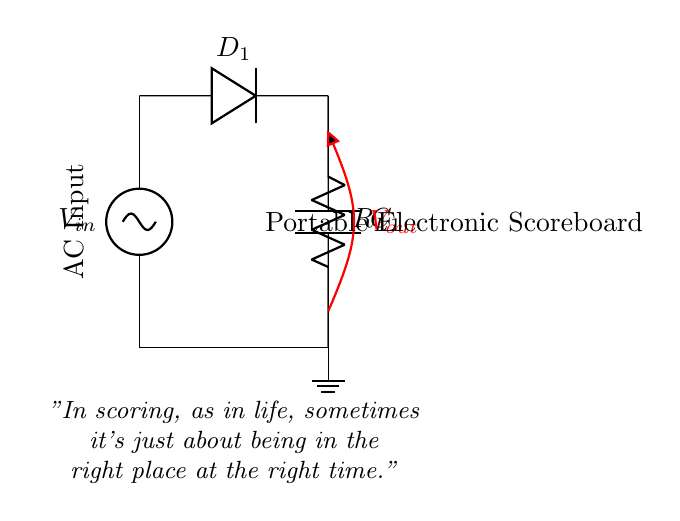What type of rectifier is used in this circuit? The circuit diagram shows a half-wave rectifier as it includes only one diode, which allows current to pass only during one half of the input AC cycle.
Answer: half-wave What is the function of the diode in this circuit? The diode (D1) allows current to flow only in one direction, thereby converting AC voltage to pulsed DC voltage, which is characteristic of a rectifier.
Answer: convert AC to DC What is the role of the capacitor in this circuit? The capacitor (C1) smooths out the pulsed DC voltage by storing charge and releasing it when the diode is not conducting, thereby reducing voltage fluctuations.
Answer: smooths voltage What is the output voltage represented in the diagram? The output voltage (Vout) is labeled in red within the circuit diagram, showing the voltage across the load resistor and capacitor combination in a rectifier circuit.
Answer: Vout How many components are in the circuit? The diagram clearly shows three main components: one diode, one capacitor, and one load resistor, which are essential for the half-wave rectification process.
Answer: three What does the load resistor represent in this circuit? The load resistor (RL) represents the part of the circuit that consumes power from the rectified output, typically serving as the device or component being powered by the scoreboard.
Answer: load What is indicated by the quote at the bottom of the diagram? The quote emphasizes the theme of chance and timing, paralleling the concept of scoring in sports with the importance of being at the right moment during the circuit's performance.
Answer: chance and timing 